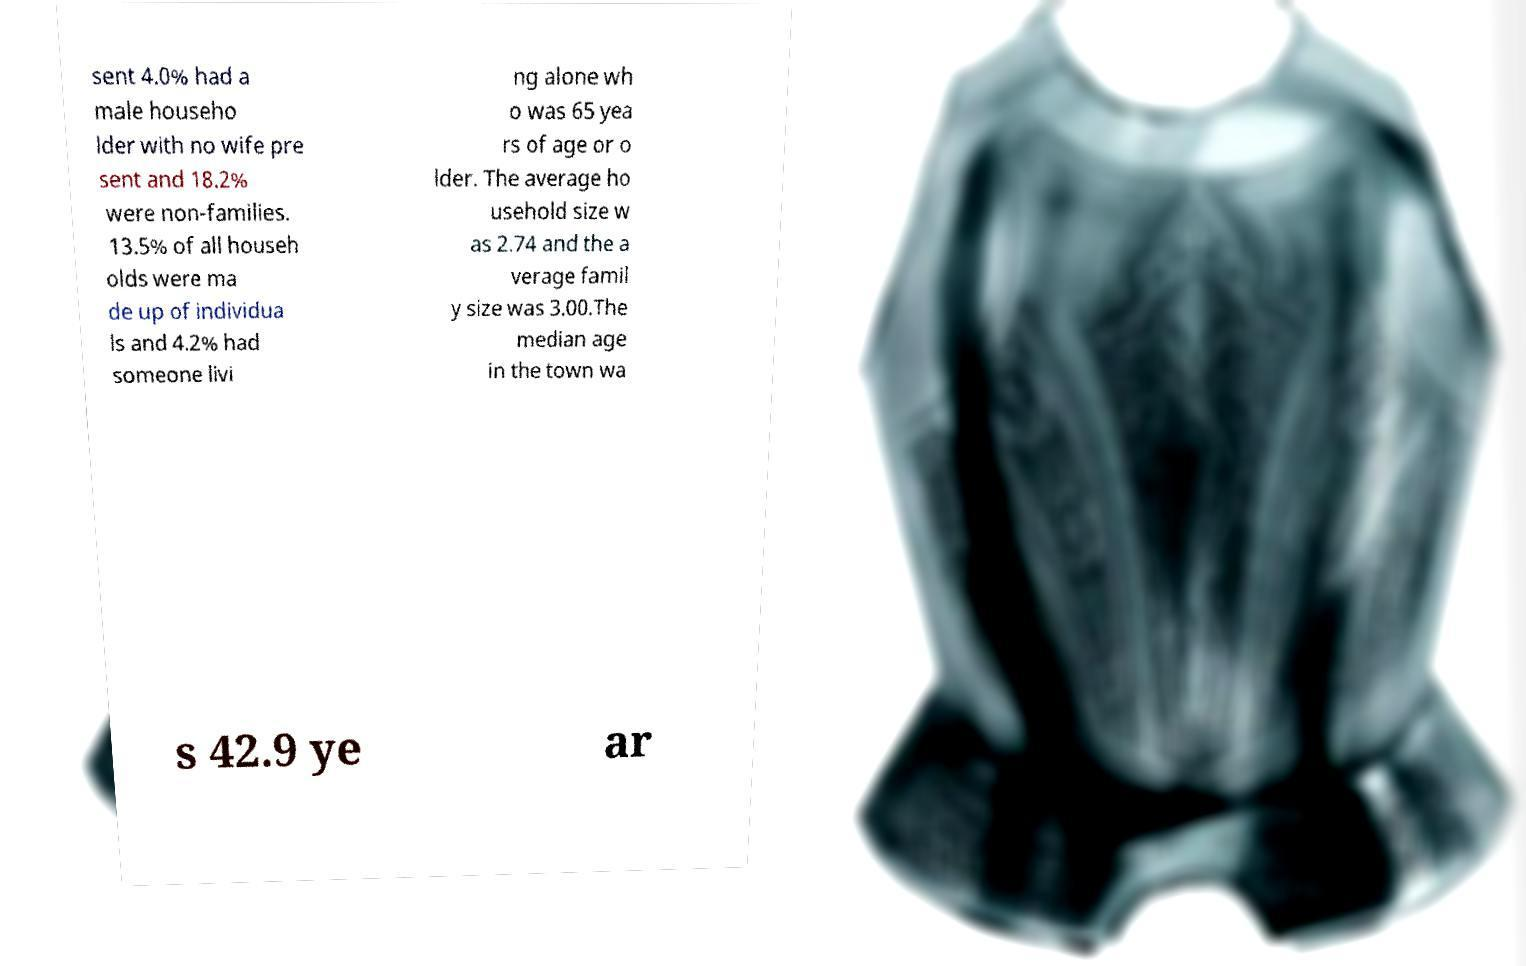Please read and relay the text visible in this image. What does it say? sent 4.0% had a male househo lder with no wife pre sent and 18.2% were non-families. 13.5% of all househ olds were ma de up of individua ls and 4.2% had someone livi ng alone wh o was 65 yea rs of age or o lder. The average ho usehold size w as 2.74 and the a verage famil y size was 3.00.The median age in the town wa s 42.9 ye ar 